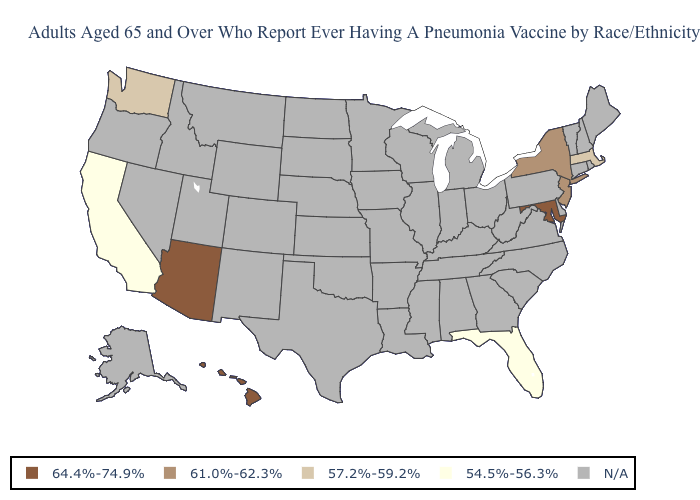What is the value of North Carolina?
Write a very short answer. N/A. What is the lowest value in the USA?
Write a very short answer. 54.5%-56.3%. How many symbols are there in the legend?
Write a very short answer. 5. Does the map have missing data?
Keep it brief. Yes. Among the states that border Rhode Island , which have the lowest value?
Answer briefly. Massachusetts. Which states hav the highest value in the South?
Keep it brief. Maryland. Does the first symbol in the legend represent the smallest category?
Be succinct. No. Which states have the lowest value in the USA?
Give a very brief answer. California, Florida. Is the legend a continuous bar?
Be succinct. No. What is the value of South Dakota?
Give a very brief answer. N/A. Among the states that border Vermont , does Massachusetts have the highest value?
Be succinct. No. 